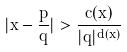<formula> <loc_0><loc_0><loc_500><loc_500>| x - \frac { p } { q } | > \frac { c ( x ) } { | q | ^ { d ( x ) } }</formula> 